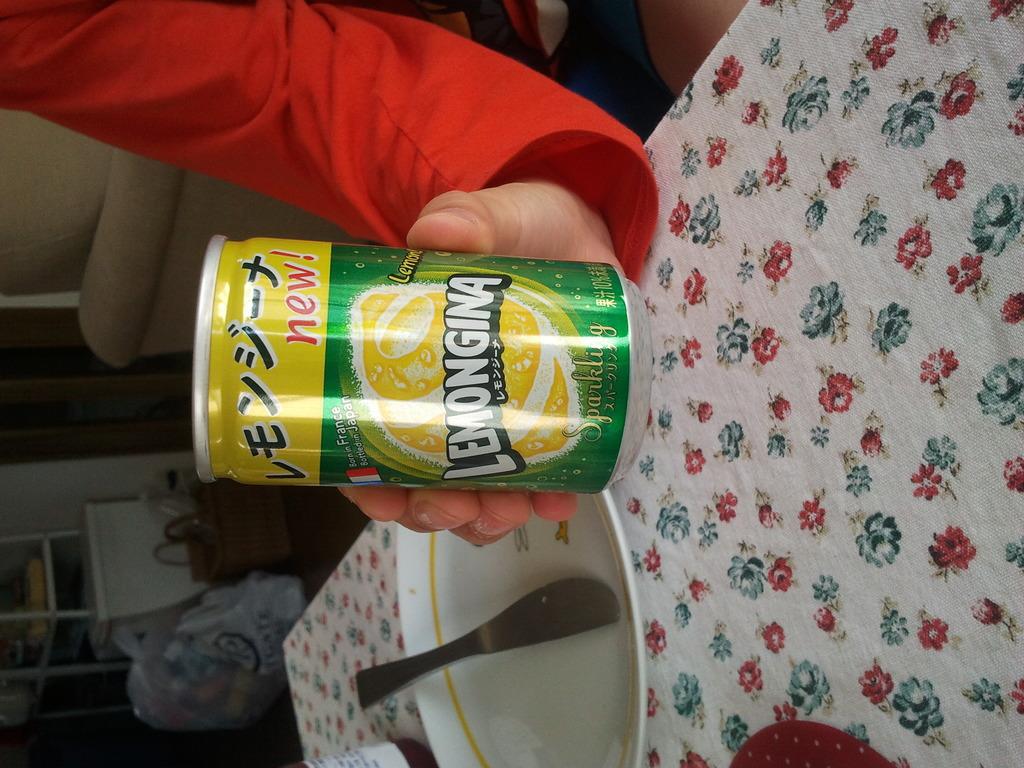What brand of beverage is this?
Keep it short and to the point. Lemongina. Where are lemonginas produced?
Provide a succinct answer. Japan. 